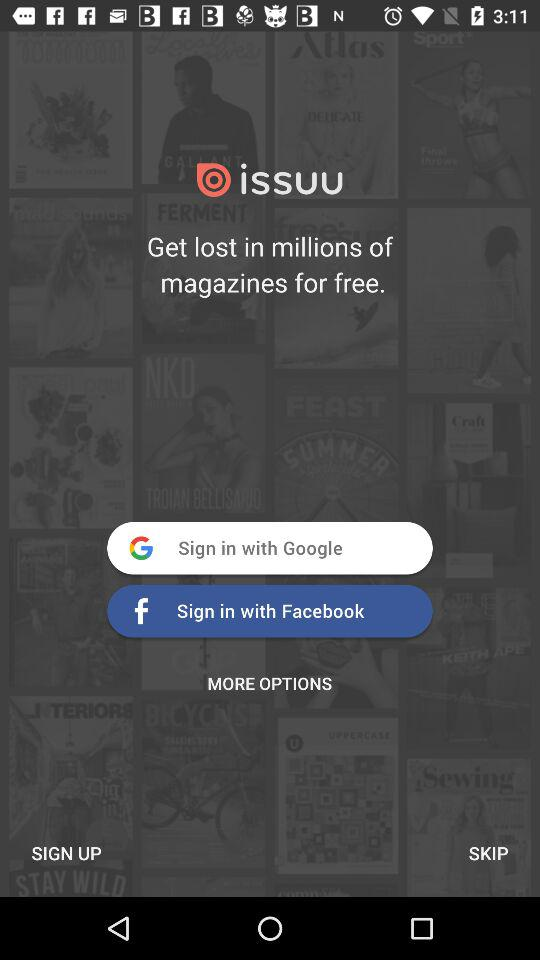Through which applications can we sign in? You can sign in through "Google" and "Facebook". 